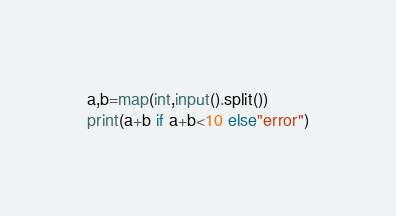<code> <loc_0><loc_0><loc_500><loc_500><_Python_>a,b=map(int,input().split())
print(a+b if a+b<10 else"error")</code> 